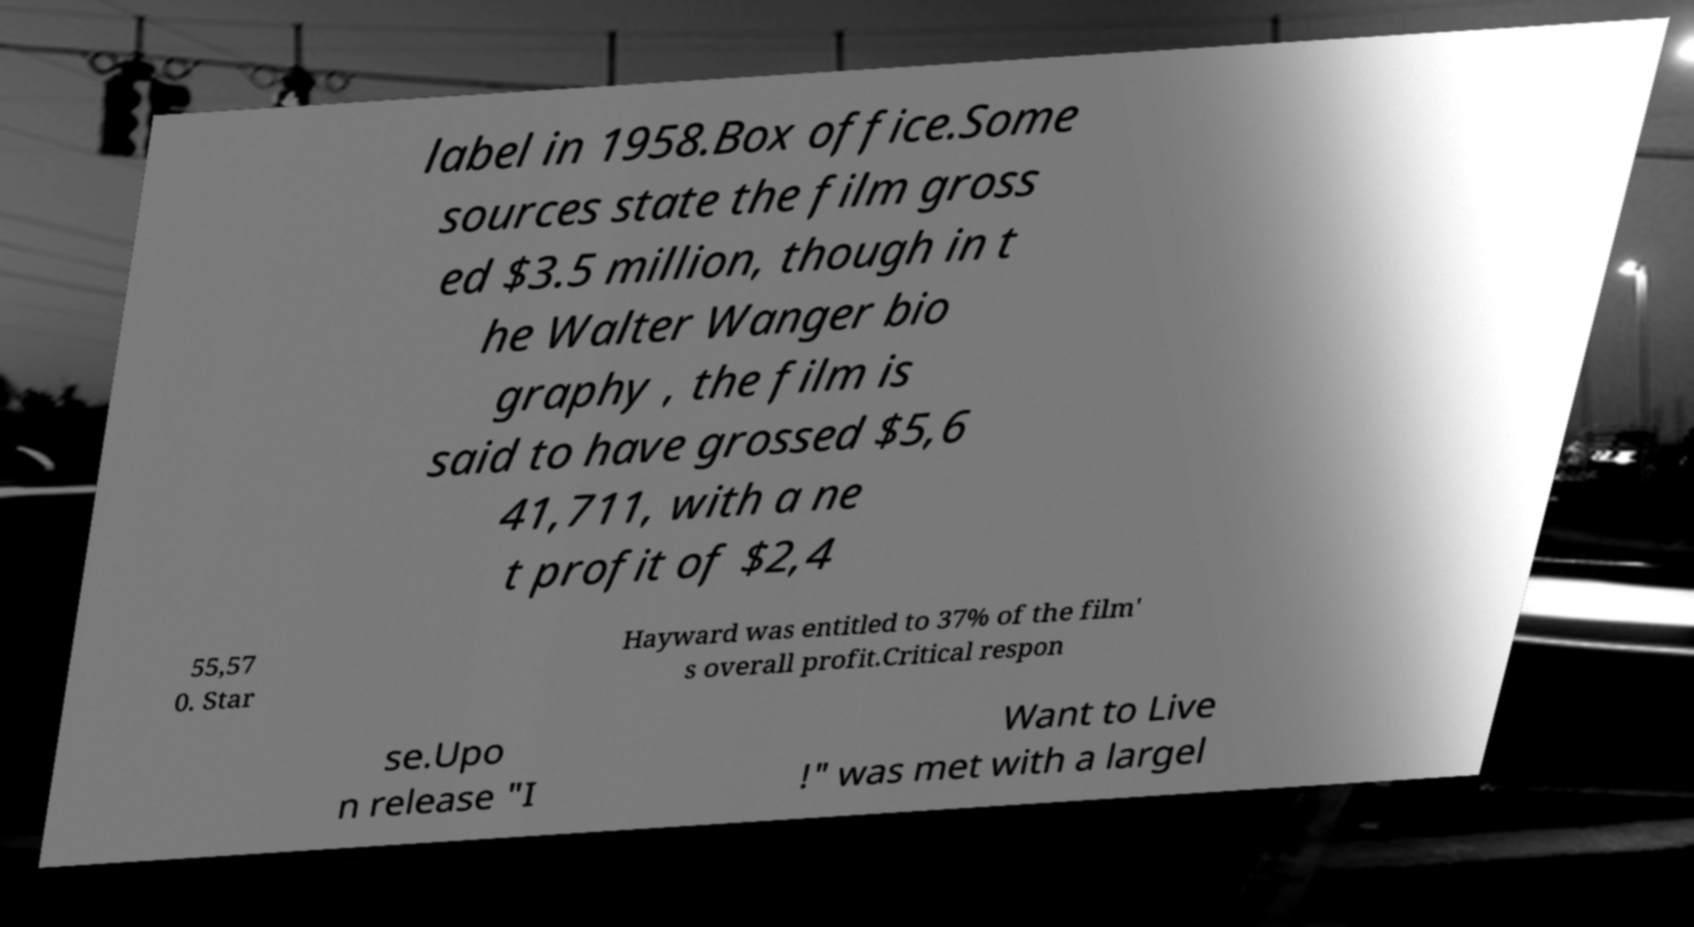For documentation purposes, I need the text within this image transcribed. Could you provide that? label in 1958.Box office.Some sources state the film gross ed $3.5 million, though in t he Walter Wanger bio graphy , the film is said to have grossed $5,6 41,711, with a ne t profit of $2,4 55,57 0. Star Hayward was entitled to 37% of the film' s overall profit.Critical respon se.Upo n release "I Want to Live !" was met with a largel 